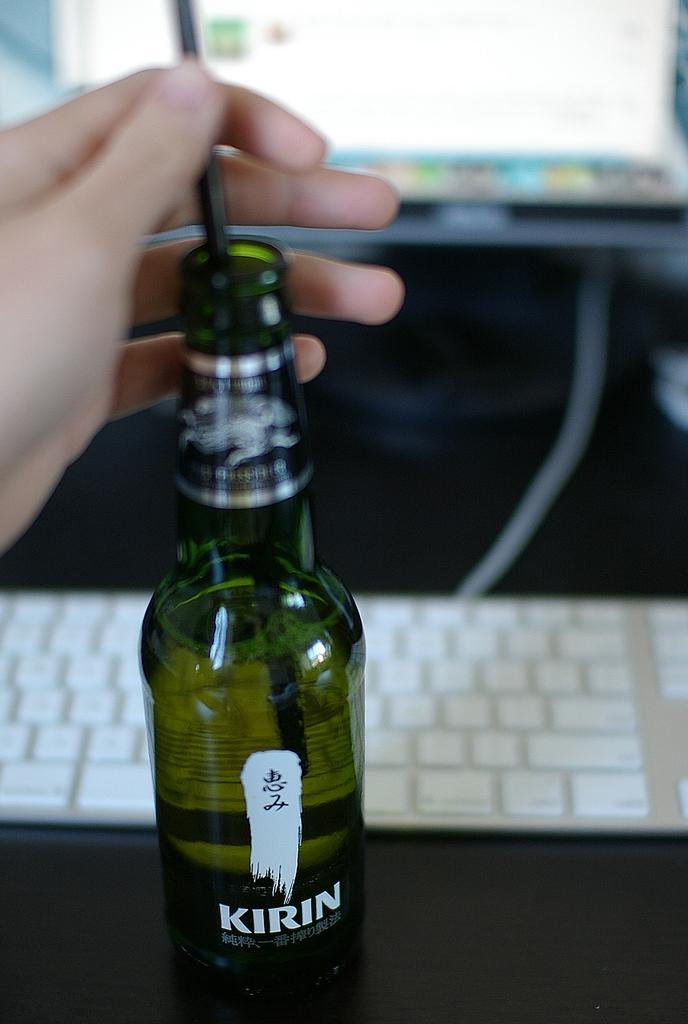<image>
Write a terse but informative summary of the picture. A hand is holding a straw in a bottle of Kirin. 